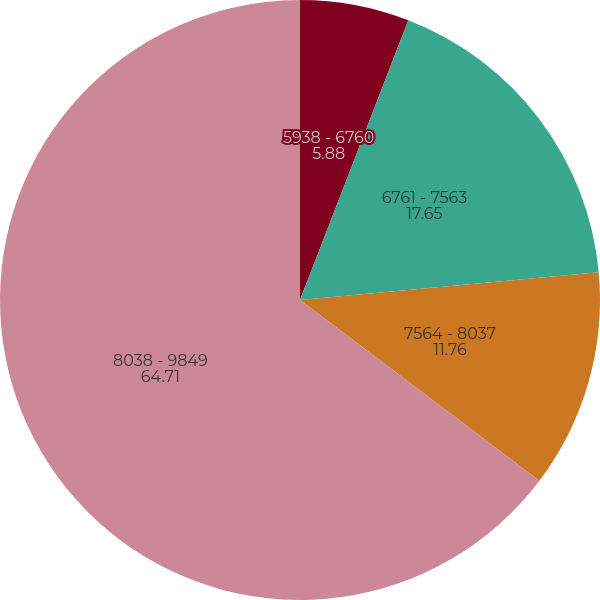<chart> <loc_0><loc_0><loc_500><loc_500><pie_chart><fcel>5938 - 6760<fcel>6761 - 7563<fcel>7564 - 8037<fcel>8038 - 9849<nl><fcel>5.88%<fcel>17.65%<fcel>11.76%<fcel>64.71%<nl></chart> 